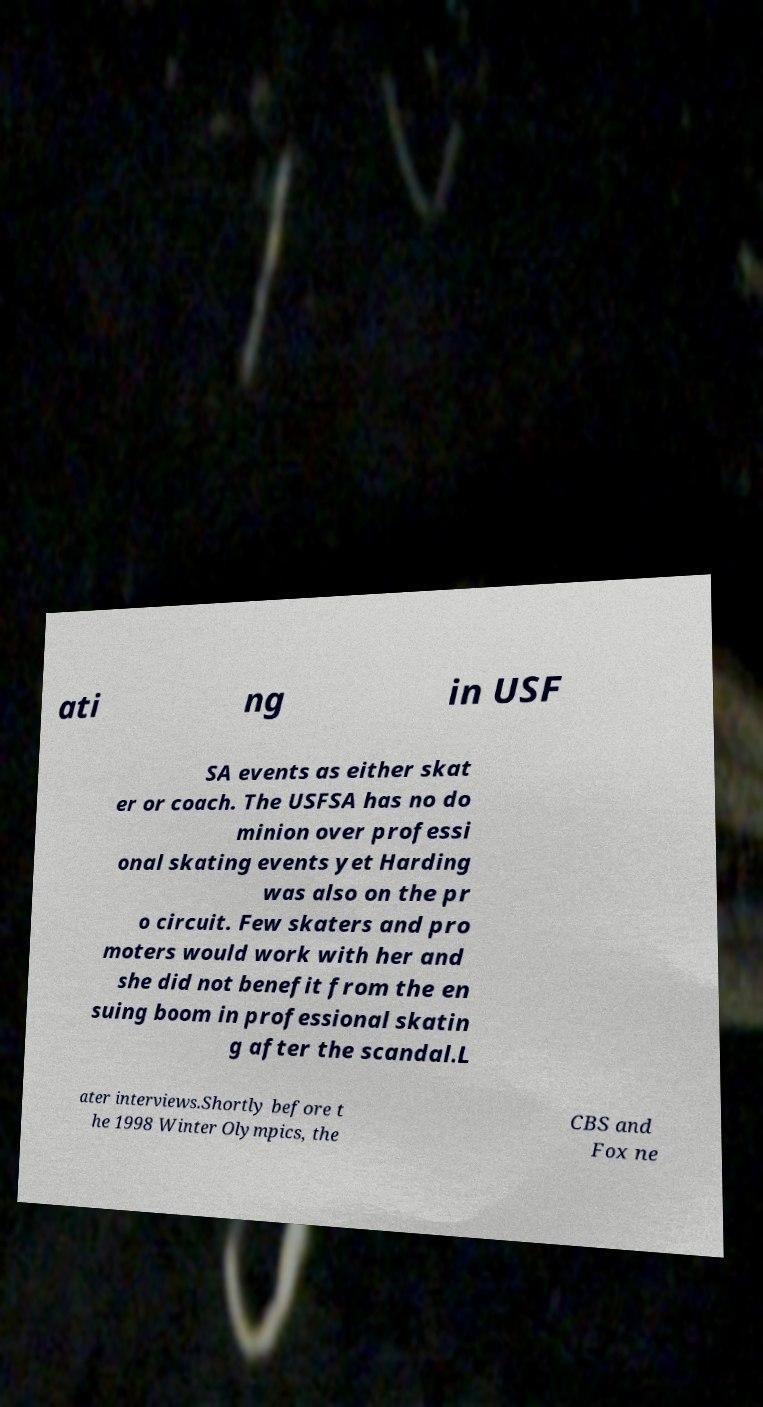Could you assist in decoding the text presented in this image and type it out clearly? ati ng in USF SA events as either skat er or coach. The USFSA has no do minion over professi onal skating events yet Harding was also on the pr o circuit. Few skaters and pro moters would work with her and she did not benefit from the en suing boom in professional skatin g after the scandal.L ater interviews.Shortly before t he 1998 Winter Olympics, the CBS and Fox ne 